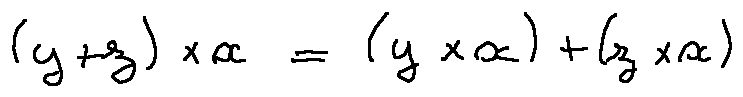<formula> <loc_0><loc_0><loc_500><loc_500>( y + z ) \times x = ( y \times x ) + ( z \times x )</formula> 